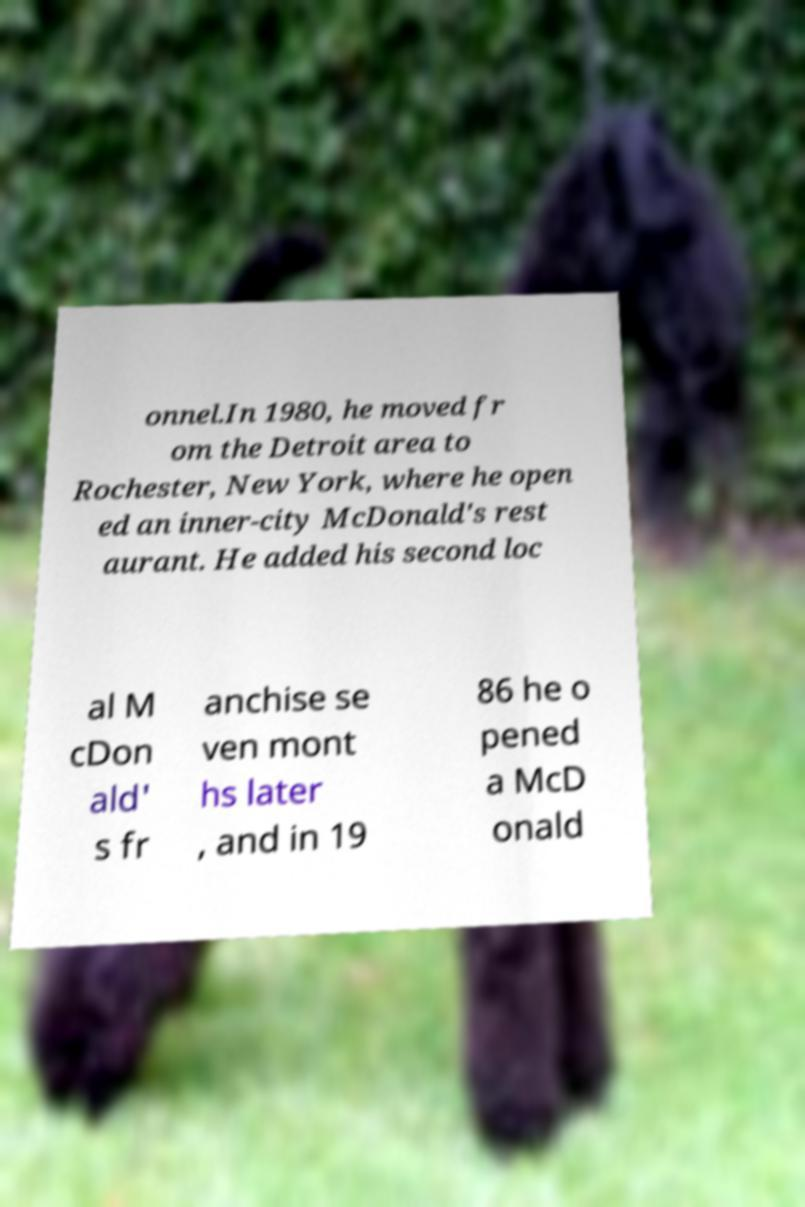What messages or text are displayed in this image? I need them in a readable, typed format. onnel.In 1980, he moved fr om the Detroit area to Rochester, New York, where he open ed an inner-city McDonald's rest aurant. He added his second loc al M cDon ald' s fr anchise se ven mont hs later , and in 19 86 he o pened a McD onald 